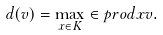<formula> <loc_0><loc_0><loc_500><loc_500>d ( v ) = \max _ { x \in K } \in p r o d { x } { v } .</formula> 